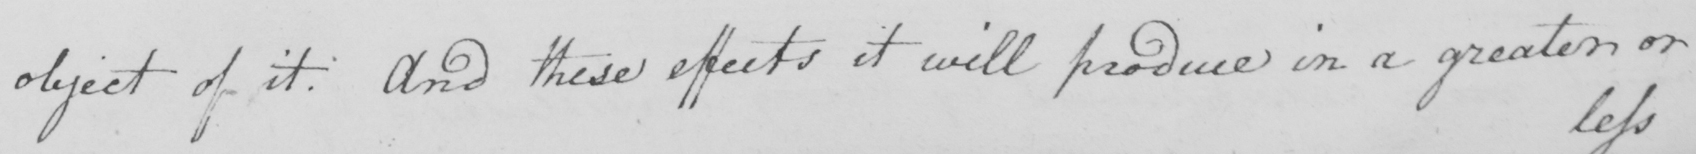Can you read and transcribe this handwriting? object of it . And these effects it will produce in a greater or 